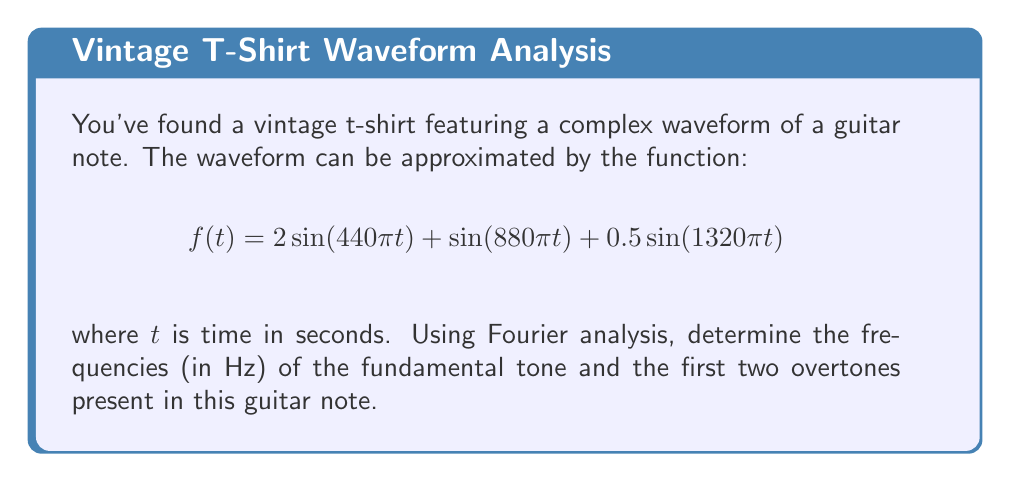Teach me how to tackle this problem. Let's approach this step-by-step:

1) The Fourier series represents a periodic function as a sum of sine and cosine terms. In this case, we're given the function already in the form of a sum of sines.

2) The general form of a sine term in a Fourier series is:

   $$A \sin(2\pi ft)$$

   where $A$ is the amplitude, $f$ is the frequency in Hz, and $t$ is time in seconds.

3) Let's compare our function to this general form:

   $$2\sin(440\pi t) + \sin(880\pi t) + 0.5\sin(1320\pi t)$$

4) For the first term:
   $$2\sin(440\pi t) = 2\sin(2\pi \cdot 220 \cdot t)$$
   So the frequency is 220 Hz, and this is our fundamental tone.

5) For the second term:
   $$\sin(880\pi t) = \sin(2\pi \cdot 440 \cdot t)$$
   The frequency is 440 Hz, which is the first overtone.

6) For the third term:
   $$0.5\sin(1320\pi t) = 0.5\sin(2\pi \cdot 660 \cdot t)$$
   The frequency is 660 Hz, which is the second overtone.

7) We can verify that 440 Hz is indeed the first overtone as it's twice the fundamental frequency, and 660 Hz is the second overtone as it's three times the fundamental frequency.
Answer: Fundamental: 220 Hz, First overtone: 440 Hz, Second overtone: 660 Hz 